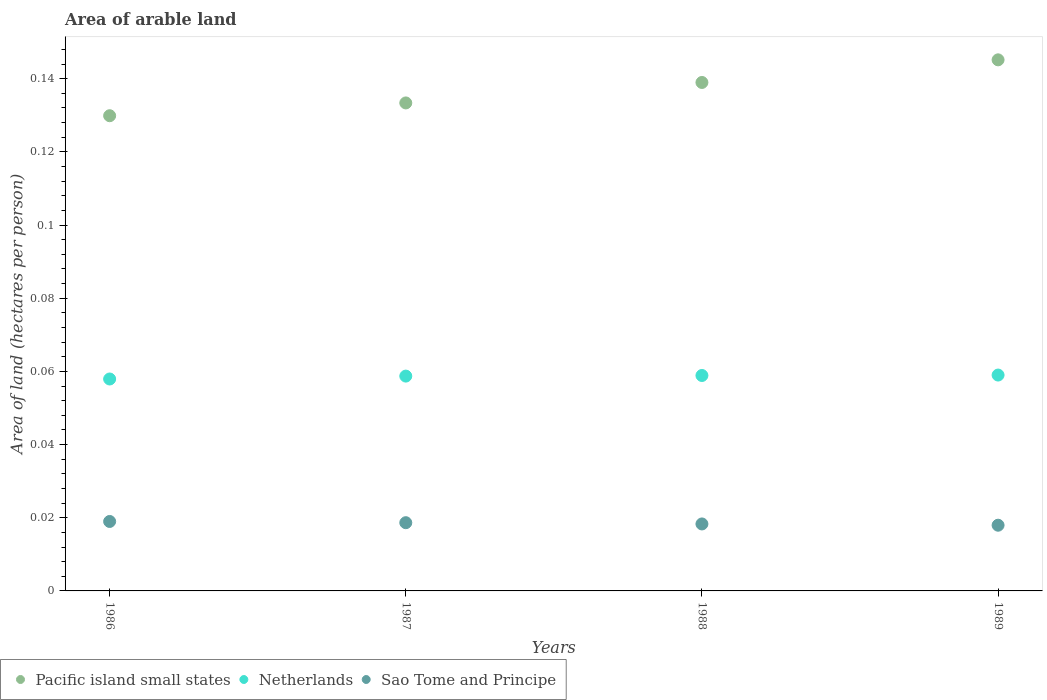Is the number of dotlines equal to the number of legend labels?
Make the answer very short. Yes. What is the total arable land in Sao Tome and Principe in 1987?
Your answer should be compact. 0.02. Across all years, what is the maximum total arable land in Pacific island small states?
Your answer should be compact. 0.15. Across all years, what is the minimum total arable land in Sao Tome and Principe?
Give a very brief answer. 0.02. In which year was the total arable land in Netherlands maximum?
Offer a very short reply. 1989. What is the total total arable land in Pacific island small states in the graph?
Make the answer very short. 0.55. What is the difference between the total arable land in Sao Tome and Principe in 1986 and that in 1989?
Provide a short and direct response. 0. What is the difference between the total arable land in Pacific island small states in 1988 and the total arable land in Netherlands in 1989?
Give a very brief answer. 0.08. What is the average total arable land in Sao Tome and Principe per year?
Your answer should be compact. 0.02. In the year 1988, what is the difference between the total arable land in Netherlands and total arable land in Pacific island small states?
Offer a terse response. -0.08. What is the ratio of the total arable land in Sao Tome and Principe in 1986 to that in 1989?
Offer a terse response. 1.06. Is the difference between the total arable land in Netherlands in 1987 and 1988 greater than the difference between the total arable land in Pacific island small states in 1987 and 1988?
Make the answer very short. Yes. What is the difference between the highest and the second highest total arable land in Pacific island small states?
Your response must be concise. 0.01. What is the difference between the highest and the lowest total arable land in Pacific island small states?
Provide a short and direct response. 0.02. Is the sum of the total arable land in Pacific island small states in 1987 and 1989 greater than the maximum total arable land in Netherlands across all years?
Keep it short and to the point. Yes. Is it the case that in every year, the sum of the total arable land in Pacific island small states and total arable land in Sao Tome and Principe  is greater than the total arable land in Netherlands?
Keep it short and to the point. Yes. Does the total arable land in Netherlands monotonically increase over the years?
Provide a succinct answer. Yes. What is the difference between two consecutive major ticks on the Y-axis?
Give a very brief answer. 0.02. Are the values on the major ticks of Y-axis written in scientific E-notation?
Ensure brevity in your answer.  No. Does the graph contain any zero values?
Keep it short and to the point. No. Does the graph contain grids?
Your answer should be compact. No. Where does the legend appear in the graph?
Give a very brief answer. Bottom left. What is the title of the graph?
Your answer should be compact. Area of arable land. Does "Swaziland" appear as one of the legend labels in the graph?
Your answer should be very brief. No. What is the label or title of the Y-axis?
Keep it short and to the point. Area of land (hectares per person). What is the Area of land (hectares per person) in Pacific island small states in 1986?
Your response must be concise. 0.13. What is the Area of land (hectares per person) in Netherlands in 1986?
Your response must be concise. 0.06. What is the Area of land (hectares per person) in Sao Tome and Principe in 1986?
Provide a succinct answer. 0.02. What is the Area of land (hectares per person) in Pacific island small states in 1987?
Offer a very short reply. 0.13. What is the Area of land (hectares per person) in Netherlands in 1987?
Provide a succinct answer. 0.06. What is the Area of land (hectares per person) of Sao Tome and Principe in 1987?
Offer a terse response. 0.02. What is the Area of land (hectares per person) of Pacific island small states in 1988?
Make the answer very short. 0.14. What is the Area of land (hectares per person) in Netherlands in 1988?
Your answer should be very brief. 0.06. What is the Area of land (hectares per person) in Sao Tome and Principe in 1988?
Offer a very short reply. 0.02. What is the Area of land (hectares per person) in Pacific island small states in 1989?
Ensure brevity in your answer.  0.15. What is the Area of land (hectares per person) of Netherlands in 1989?
Your answer should be compact. 0.06. What is the Area of land (hectares per person) in Sao Tome and Principe in 1989?
Offer a terse response. 0.02. Across all years, what is the maximum Area of land (hectares per person) of Pacific island small states?
Provide a short and direct response. 0.15. Across all years, what is the maximum Area of land (hectares per person) of Netherlands?
Keep it short and to the point. 0.06. Across all years, what is the maximum Area of land (hectares per person) in Sao Tome and Principe?
Your answer should be very brief. 0.02. Across all years, what is the minimum Area of land (hectares per person) of Pacific island small states?
Offer a terse response. 0.13. Across all years, what is the minimum Area of land (hectares per person) in Netherlands?
Ensure brevity in your answer.  0.06. Across all years, what is the minimum Area of land (hectares per person) in Sao Tome and Principe?
Ensure brevity in your answer.  0.02. What is the total Area of land (hectares per person) of Pacific island small states in the graph?
Provide a succinct answer. 0.55. What is the total Area of land (hectares per person) of Netherlands in the graph?
Offer a very short reply. 0.23. What is the total Area of land (hectares per person) of Sao Tome and Principe in the graph?
Keep it short and to the point. 0.07. What is the difference between the Area of land (hectares per person) of Pacific island small states in 1986 and that in 1987?
Ensure brevity in your answer.  -0. What is the difference between the Area of land (hectares per person) of Netherlands in 1986 and that in 1987?
Give a very brief answer. -0. What is the difference between the Area of land (hectares per person) of Sao Tome and Principe in 1986 and that in 1987?
Give a very brief answer. 0. What is the difference between the Area of land (hectares per person) of Pacific island small states in 1986 and that in 1988?
Your answer should be compact. -0.01. What is the difference between the Area of land (hectares per person) of Netherlands in 1986 and that in 1988?
Provide a succinct answer. -0. What is the difference between the Area of land (hectares per person) of Sao Tome and Principe in 1986 and that in 1988?
Give a very brief answer. 0. What is the difference between the Area of land (hectares per person) of Pacific island small states in 1986 and that in 1989?
Your answer should be compact. -0.02. What is the difference between the Area of land (hectares per person) in Netherlands in 1986 and that in 1989?
Your answer should be compact. -0. What is the difference between the Area of land (hectares per person) in Sao Tome and Principe in 1986 and that in 1989?
Give a very brief answer. 0. What is the difference between the Area of land (hectares per person) in Pacific island small states in 1987 and that in 1988?
Your response must be concise. -0.01. What is the difference between the Area of land (hectares per person) of Netherlands in 1987 and that in 1988?
Offer a terse response. -0. What is the difference between the Area of land (hectares per person) in Sao Tome and Principe in 1987 and that in 1988?
Provide a short and direct response. 0. What is the difference between the Area of land (hectares per person) in Pacific island small states in 1987 and that in 1989?
Your response must be concise. -0.01. What is the difference between the Area of land (hectares per person) in Netherlands in 1987 and that in 1989?
Offer a very short reply. -0. What is the difference between the Area of land (hectares per person) in Sao Tome and Principe in 1987 and that in 1989?
Ensure brevity in your answer.  0. What is the difference between the Area of land (hectares per person) of Pacific island small states in 1988 and that in 1989?
Your response must be concise. -0.01. What is the difference between the Area of land (hectares per person) in Netherlands in 1988 and that in 1989?
Your answer should be very brief. -0. What is the difference between the Area of land (hectares per person) in Sao Tome and Principe in 1988 and that in 1989?
Give a very brief answer. 0. What is the difference between the Area of land (hectares per person) of Pacific island small states in 1986 and the Area of land (hectares per person) of Netherlands in 1987?
Make the answer very short. 0.07. What is the difference between the Area of land (hectares per person) of Pacific island small states in 1986 and the Area of land (hectares per person) of Sao Tome and Principe in 1987?
Your answer should be very brief. 0.11. What is the difference between the Area of land (hectares per person) of Netherlands in 1986 and the Area of land (hectares per person) of Sao Tome and Principe in 1987?
Ensure brevity in your answer.  0.04. What is the difference between the Area of land (hectares per person) in Pacific island small states in 1986 and the Area of land (hectares per person) in Netherlands in 1988?
Offer a very short reply. 0.07. What is the difference between the Area of land (hectares per person) in Pacific island small states in 1986 and the Area of land (hectares per person) in Sao Tome and Principe in 1988?
Offer a terse response. 0.11. What is the difference between the Area of land (hectares per person) in Netherlands in 1986 and the Area of land (hectares per person) in Sao Tome and Principe in 1988?
Make the answer very short. 0.04. What is the difference between the Area of land (hectares per person) of Pacific island small states in 1986 and the Area of land (hectares per person) of Netherlands in 1989?
Your response must be concise. 0.07. What is the difference between the Area of land (hectares per person) in Pacific island small states in 1986 and the Area of land (hectares per person) in Sao Tome and Principe in 1989?
Ensure brevity in your answer.  0.11. What is the difference between the Area of land (hectares per person) of Pacific island small states in 1987 and the Area of land (hectares per person) of Netherlands in 1988?
Make the answer very short. 0.07. What is the difference between the Area of land (hectares per person) of Pacific island small states in 1987 and the Area of land (hectares per person) of Sao Tome and Principe in 1988?
Ensure brevity in your answer.  0.12. What is the difference between the Area of land (hectares per person) of Netherlands in 1987 and the Area of land (hectares per person) of Sao Tome and Principe in 1988?
Make the answer very short. 0.04. What is the difference between the Area of land (hectares per person) in Pacific island small states in 1987 and the Area of land (hectares per person) in Netherlands in 1989?
Your response must be concise. 0.07. What is the difference between the Area of land (hectares per person) of Pacific island small states in 1987 and the Area of land (hectares per person) of Sao Tome and Principe in 1989?
Keep it short and to the point. 0.12. What is the difference between the Area of land (hectares per person) of Netherlands in 1987 and the Area of land (hectares per person) of Sao Tome and Principe in 1989?
Ensure brevity in your answer.  0.04. What is the difference between the Area of land (hectares per person) in Pacific island small states in 1988 and the Area of land (hectares per person) in Netherlands in 1989?
Provide a succinct answer. 0.08. What is the difference between the Area of land (hectares per person) in Pacific island small states in 1988 and the Area of land (hectares per person) in Sao Tome and Principe in 1989?
Ensure brevity in your answer.  0.12. What is the difference between the Area of land (hectares per person) in Netherlands in 1988 and the Area of land (hectares per person) in Sao Tome and Principe in 1989?
Make the answer very short. 0.04. What is the average Area of land (hectares per person) of Pacific island small states per year?
Ensure brevity in your answer.  0.14. What is the average Area of land (hectares per person) of Netherlands per year?
Provide a short and direct response. 0.06. What is the average Area of land (hectares per person) in Sao Tome and Principe per year?
Your response must be concise. 0.02. In the year 1986, what is the difference between the Area of land (hectares per person) of Pacific island small states and Area of land (hectares per person) of Netherlands?
Your answer should be compact. 0.07. In the year 1986, what is the difference between the Area of land (hectares per person) in Pacific island small states and Area of land (hectares per person) in Sao Tome and Principe?
Your response must be concise. 0.11. In the year 1986, what is the difference between the Area of land (hectares per person) of Netherlands and Area of land (hectares per person) of Sao Tome and Principe?
Your answer should be compact. 0.04. In the year 1987, what is the difference between the Area of land (hectares per person) in Pacific island small states and Area of land (hectares per person) in Netherlands?
Your answer should be very brief. 0.07. In the year 1987, what is the difference between the Area of land (hectares per person) in Pacific island small states and Area of land (hectares per person) in Sao Tome and Principe?
Offer a terse response. 0.11. In the year 1987, what is the difference between the Area of land (hectares per person) of Netherlands and Area of land (hectares per person) of Sao Tome and Principe?
Your answer should be very brief. 0.04. In the year 1988, what is the difference between the Area of land (hectares per person) in Pacific island small states and Area of land (hectares per person) in Netherlands?
Ensure brevity in your answer.  0.08. In the year 1988, what is the difference between the Area of land (hectares per person) of Pacific island small states and Area of land (hectares per person) of Sao Tome and Principe?
Your response must be concise. 0.12. In the year 1988, what is the difference between the Area of land (hectares per person) in Netherlands and Area of land (hectares per person) in Sao Tome and Principe?
Provide a short and direct response. 0.04. In the year 1989, what is the difference between the Area of land (hectares per person) of Pacific island small states and Area of land (hectares per person) of Netherlands?
Ensure brevity in your answer.  0.09. In the year 1989, what is the difference between the Area of land (hectares per person) in Pacific island small states and Area of land (hectares per person) in Sao Tome and Principe?
Offer a very short reply. 0.13. In the year 1989, what is the difference between the Area of land (hectares per person) in Netherlands and Area of land (hectares per person) in Sao Tome and Principe?
Your answer should be compact. 0.04. What is the ratio of the Area of land (hectares per person) in Pacific island small states in 1986 to that in 1987?
Provide a succinct answer. 0.97. What is the ratio of the Area of land (hectares per person) in Netherlands in 1986 to that in 1987?
Offer a very short reply. 0.99. What is the ratio of the Area of land (hectares per person) in Pacific island small states in 1986 to that in 1988?
Keep it short and to the point. 0.93. What is the ratio of the Area of land (hectares per person) in Netherlands in 1986 to that in 1988?
Make the answer very short. 0.98. What is the ratio of the Area of land (hectares per person) in Sao Tome and Principe in 1986 to that in 1988?
Give a very brief answer. 1.04. What is the ratio of the Area of land (hectares per person) in Pacific island small states in 1986 to that in 1989?
Offer a very short reply. 0.89. What is the ratio of the Area of land (hectares per person) in Netherlands in 1986 to that in 1989?
Provide a succinct answer. 0.98. What is the ratio of the Area of land (hectares per person) in Sao Tome and Principe in 1986 to that in 1989?
Your response must be concise. 1.06. What is the ratio of the Area of land (hectares per person) of Pacific island small states in 1987 to that in 1988?
Give a very brief answer. 0.96. What is the ratio of the Area of land (hectares per person) of Netherlands in 1987 to that in 1988?
Ensure brevity in your answer.  1. What is the ratio of the Area of land (hectares per person) of Sao Tome and Principe in 1987 to that in 1988?
Provide a short and direct response. 1.02. What is the ratio of the Area of land (hectares per person) in Pacific island small states in 1987 to that in 1989?
Offer a very short reply. 0.92. What is the ratio of the Area of land (hectares per person) of Netherlands in 1987 to that in 1989?
Your response must be concise. 1. What is the ratio of the Area of land (hectares per person) of Sao Tome and Principe in 1987 to that in 1989?
Provide a succinct answer. 1.04. What is the ratio of the Area of land (hectares per person) in Pacific island small states in 1988 to that in 1989?
Ensure brevity in your answer.  0.96. What is the ratio of the Area of land (hectares per person) in Sao Tome and Principe in 1988 to that in 1989?
Provide a succinct answer. 1.02. What is the difference between the highest and the second highest Area of land (hectares per person) in Pacific island small states?
Your answer should be compact. 0.01. What is the difference between the highest and the second highest Area of land (hectares per person) in Netherlands?
Provide a short and direct response. 0. What is the difference between the highest and the second highest Area of land (hectares per person) in Sao Tome and Principe?
Give a very brief answer. 0. What is the difference between the highest and the lowest Area of land (hectares per person) of Pacific island small states?
Offer a very short reply. 0.02. What is the difference between the highest and the lowest Area of land (hectares per person) of Netherlands?
Keep it short and to the point. 0. What is the difference between the highest and the lowest Area of land (hectares per person) of Sao Tome and Principe?
Provide a short and direct response. 0. 